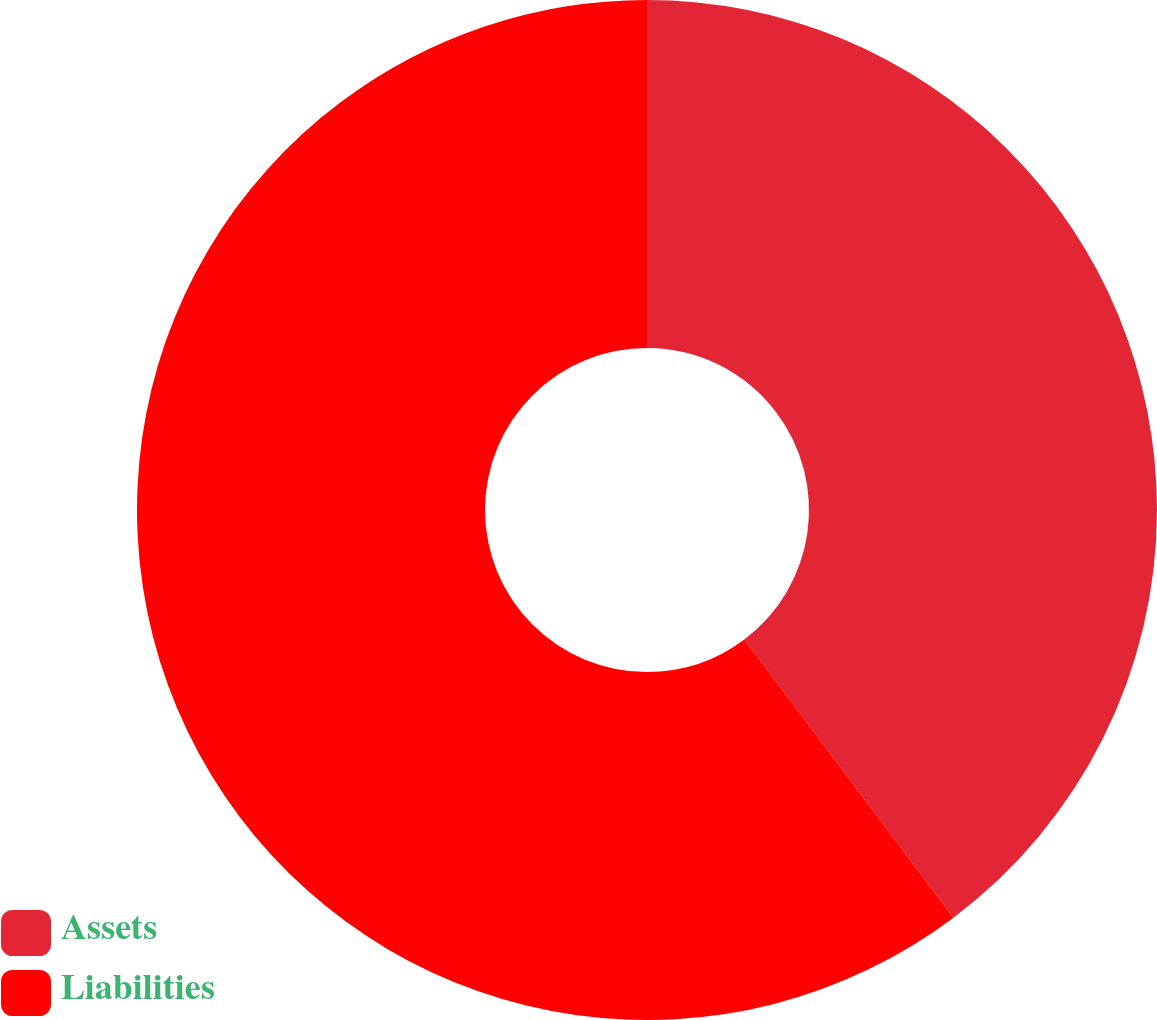Convert chart. <chart><loc_0><loc_0><loc_500><loc_500><pie_chart><fcel>Assets<fcel>Liabilities<nl><fcel>39.74%<fcel>60.26%<nl></chart> 